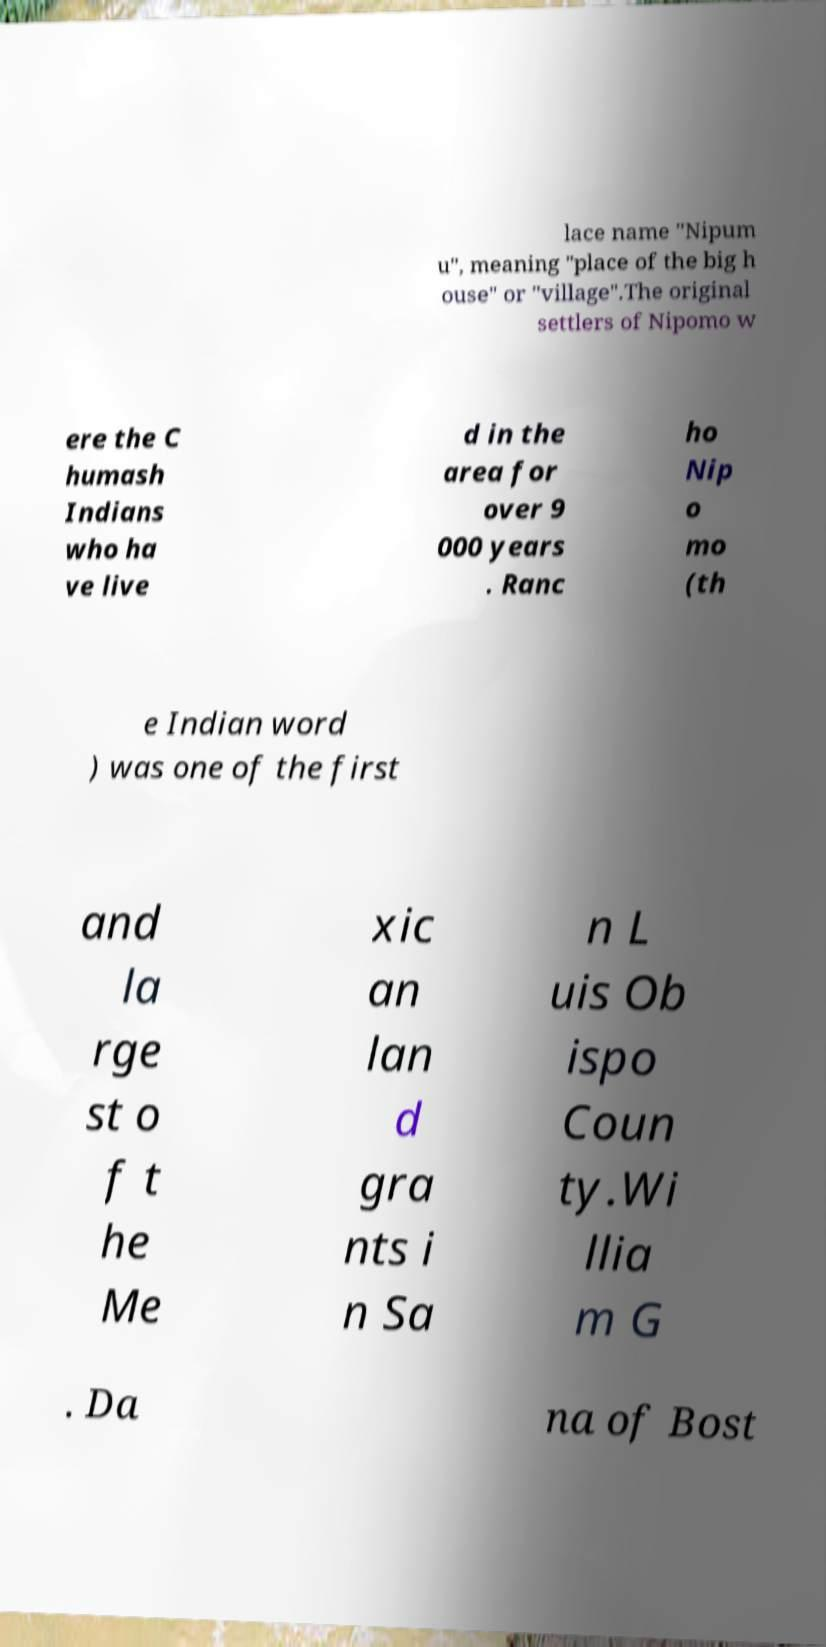There's text embedded in this image that I need extracted. Can you transcribe it verbatim? lace name "Nipum u", meaning "place of the big h ouse" or "village".The original settlers of Nipomo w ere the C humash Indians who ha ve live d in the area for over 9 000 years . Ranc ho Nip o mo (th e Indian word ) was one of the first and la rge st o f t he Me xic an lan d gra nts i n Sa n L uis Ob ispo Coun ty.Wi llia m G . Da na of Bost 